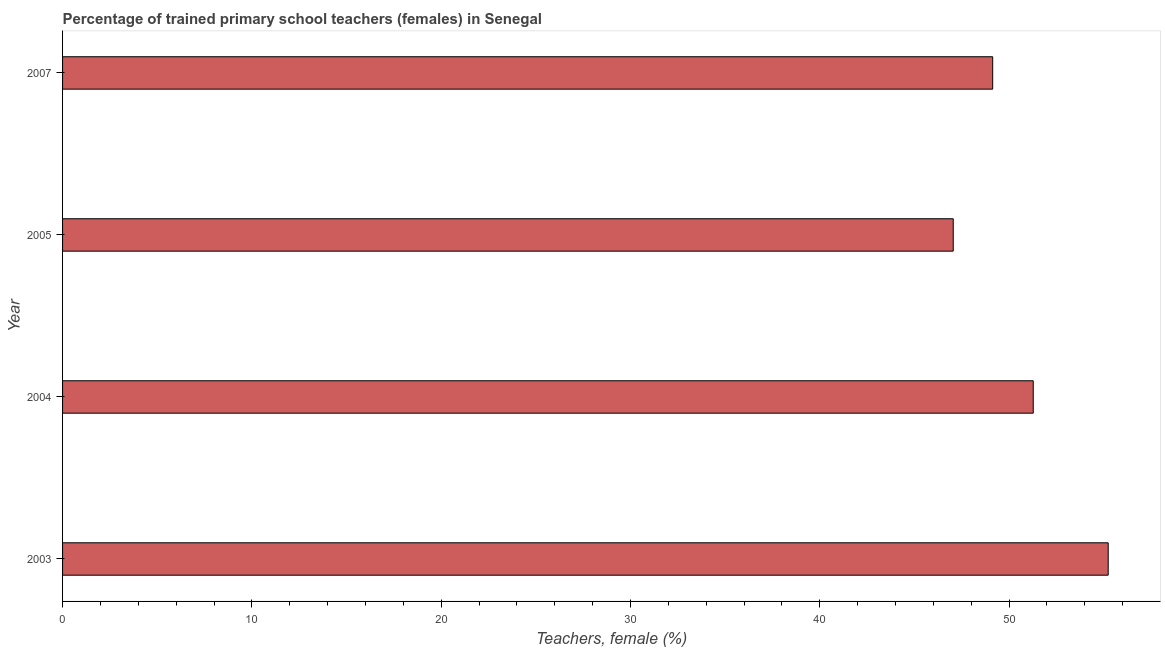Does the graph contain grids?
Your answer should be very brief. No. What is the title of the graph?
Offer a terse response. Percentage of trained primary school teachers (females) in Senegal. What is the label or title of the X-axis?
Your answer should be very brief. Teachers, female (%). What is the percentage of trained female teachers in 2007?
Keep it short and to the point. 49.13. Across all years, what is the maximum percentage of trained female teachers?
Your answer should be very brief. 55.24. Across all years, what is the minimum percentage of trained female teachers?
Your answer should be compact. 47.05. In which year was the percentage of trained female teachers maximum?
Offer a terse response. 2003. What is the sum of the percentage of trained female teachers?
Provide a succinct answer. 202.69. What is the difference between the percentage of trained female teachers in 2004 and 2005?
Provide a short and direct response. 4.23. What is the average percentage of trained female teachers per year?
Offer a terse response. 50.67. What is the median percentage of trained female teachers?
Your response must be concise. 50.2. In how many years, is the percentage of trained female teachers greater than 14 %?
Ensure brevity in your answer.  4. Do a majority of the years between 2003 and 2004 (inclusive) have percentage of trained female teachers greater than 6 %?
Offer a terse response. Yes. What is the ratio of the percentage of trained female teachers in 2004 to that in 2007?
Offer a terse response. 1.04. Is the percentage of trained female teachers in 2005 less than that in 2007?
Ensure brevity in your answer.  Yes. Is the difference between the percentage of trained female teachers in 2003 and 2007 greater than the difference between any two years?
Offer a terse response. No. What is the difference between the highest and the second highest percentage of trained female teachers?
Provide a short and direct response. 3.96. What is the difference between the highest and the lowest percentage of trained female teachers?
Your answer should be very brief. 8.19. Are all the bars in the graph horizontal?
Provide a short and direct response. Yes. Are the values on the major ticks of X-axis written in scientific E-notation?
Provide a short and direct response. No. What is the Teachers, female (%) in 2003?
Your answer should be very brief. 55.24. What is the Teachers, female (%) in 2004?
Keep it short and to the point. 51.28. What is the Teachers, female (%) of 2005?
Give a very brief answer. 47.05. What is the Teachers, female (%) in 2007?
Ensure brevity in your answer.  49.13. What is the difference between the Teachers, female (%) in 2003 and 2004?
Your answer should be very brief. 3.96. What is the difference between the Teachers, female (%) in 2003 and 2005?
Your response must be concise. 8.19. What is the difference between the Teachers, female (%) in 2003 and 2007?
Give a very brief answer. 6.1. What is the difference between the Teachers, female (%) in 2004 and 2005?
Provide a short and direct response. 4.23. What is the difference between the Teachers, female (%) in 2004 and 2007?
Offer a terse response. 2.14. What is the difference between the Teachers, female (%) in 2005 and 2007?
Offer a very short reply. -2.08. What is the ratio of the Teachers, female (%) in 2003 to that in 2004?
Your answer should be compact. 1.08. What is the ratio of the Teachers, female (%) in 2003 to that in 2005?
Ensure brevity in your answer.  1.17. What is the ratio of the Teachers, female (%) in 2003 to that in 2007?
Provide a short and direct response. 1.12. What is the ratio of the Teachers, female (%) in 2004 to that in 2005?
Make the answer very short. 1.09. What is the ratio of the Teachers, female (%) in 2004 to that in 2007?
Your response must be concise. 1.04. What is the ratio of the Teachers, female (%) in 2005 to that in 2007?
Give a very brief answer. 0.96. 